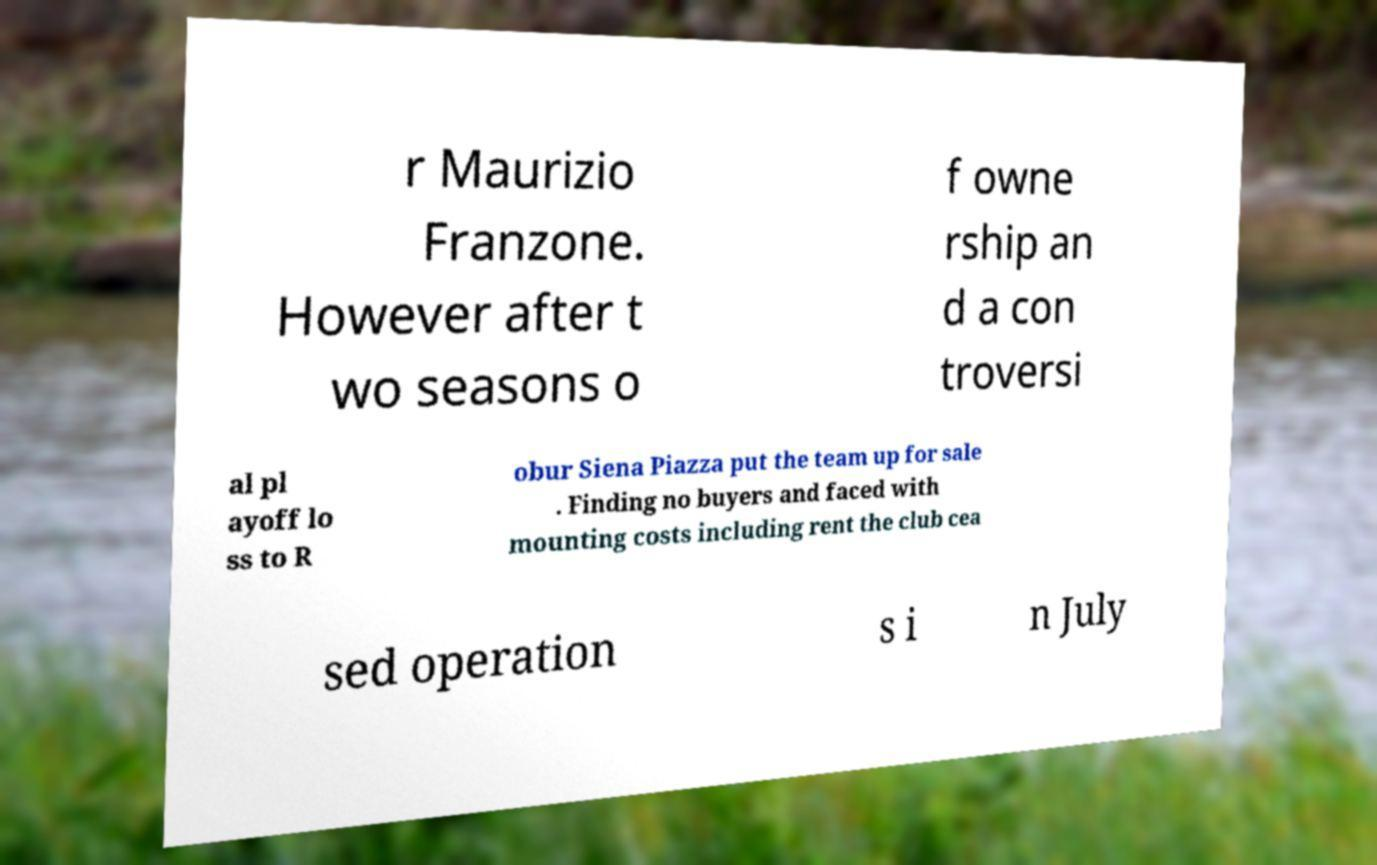Please identify and transcribe the text found in this image. r Maurizio Franzone. However after t wo seasons o f owne rship an d a con troversi al pl ayoff lo ss to R obur Siena Piazza put the team up for sale . Finding no buyers and faced with mounting costs including rent the club cea sed operation s i n July 